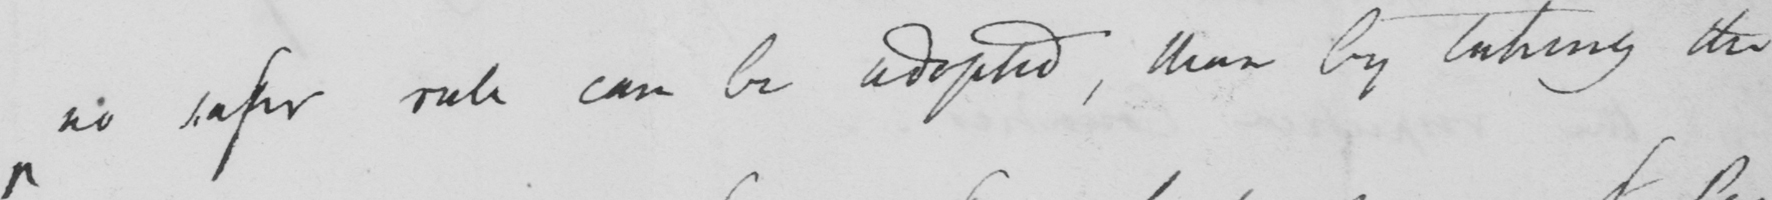Please provide the text content of this handwritten line. no safer rule can be adopted, than by taking the 